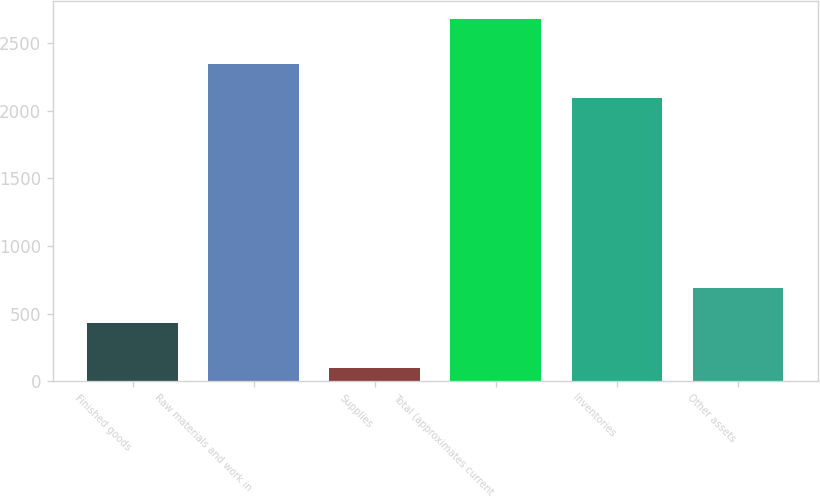Convert chart to OTSL. <chart><loc_0><loc_0><loc_500><loc_500><bar_chart><fcel>Finished goods<fcel>Raw materials and work in<fcel>Supplies<fcel>Total (approximates current<fcel>Inventories<fcel>Other assets<nl><fcel>432.6<fcel>2348.97<fcel>98.6<fcel>2678.3<fcel>2091<fcel>690.57<nl></chart> 